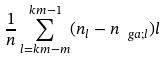<formula> <loc_0><loc_0><loc_500><loc_500>\frac { 1 } { n } \sum _ { l = k m - m } ^ { k m - 1 } ( n _ { l } - n _ { \ g a ; l } ) l</formula> 